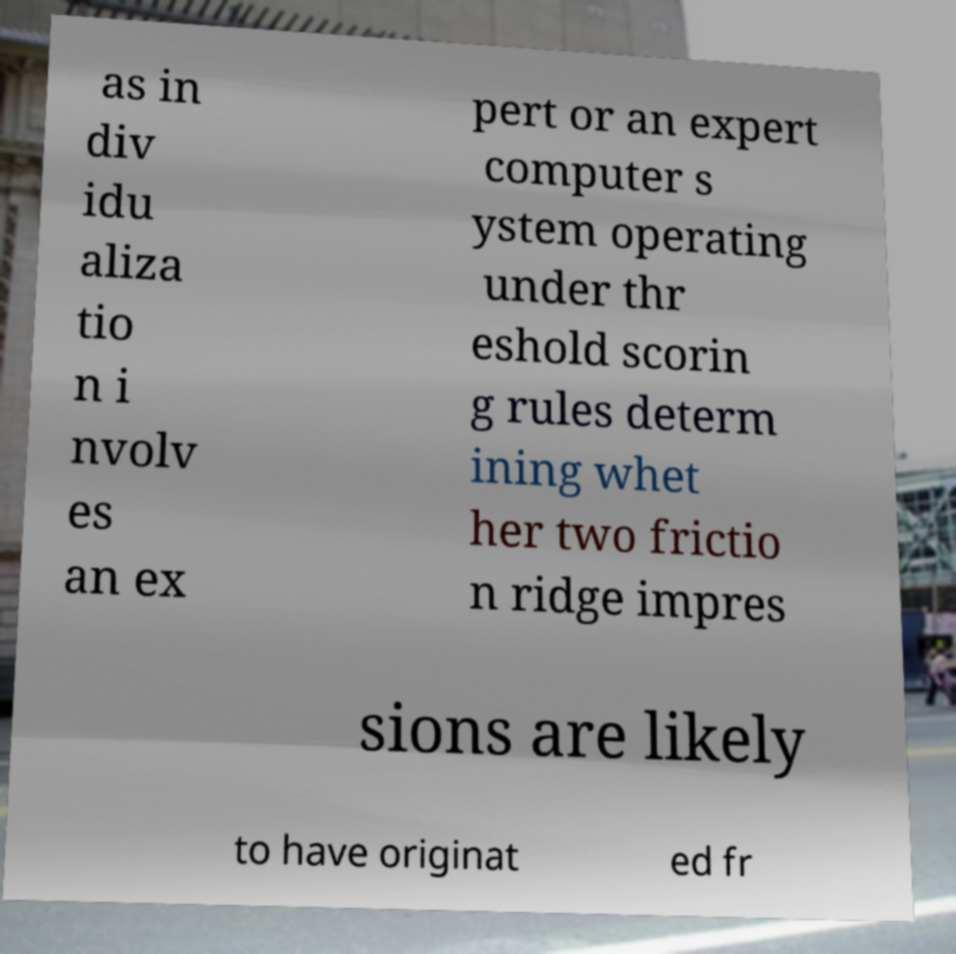Please identify and transcribe the text found in this image. as in div idu aliza tio n i nvolv es an ex pert or an expert computer s ystem operating under thr eshold scorin g rules determ ining whet her two frictio n ridge impres sions are likely to have originat ed fr 